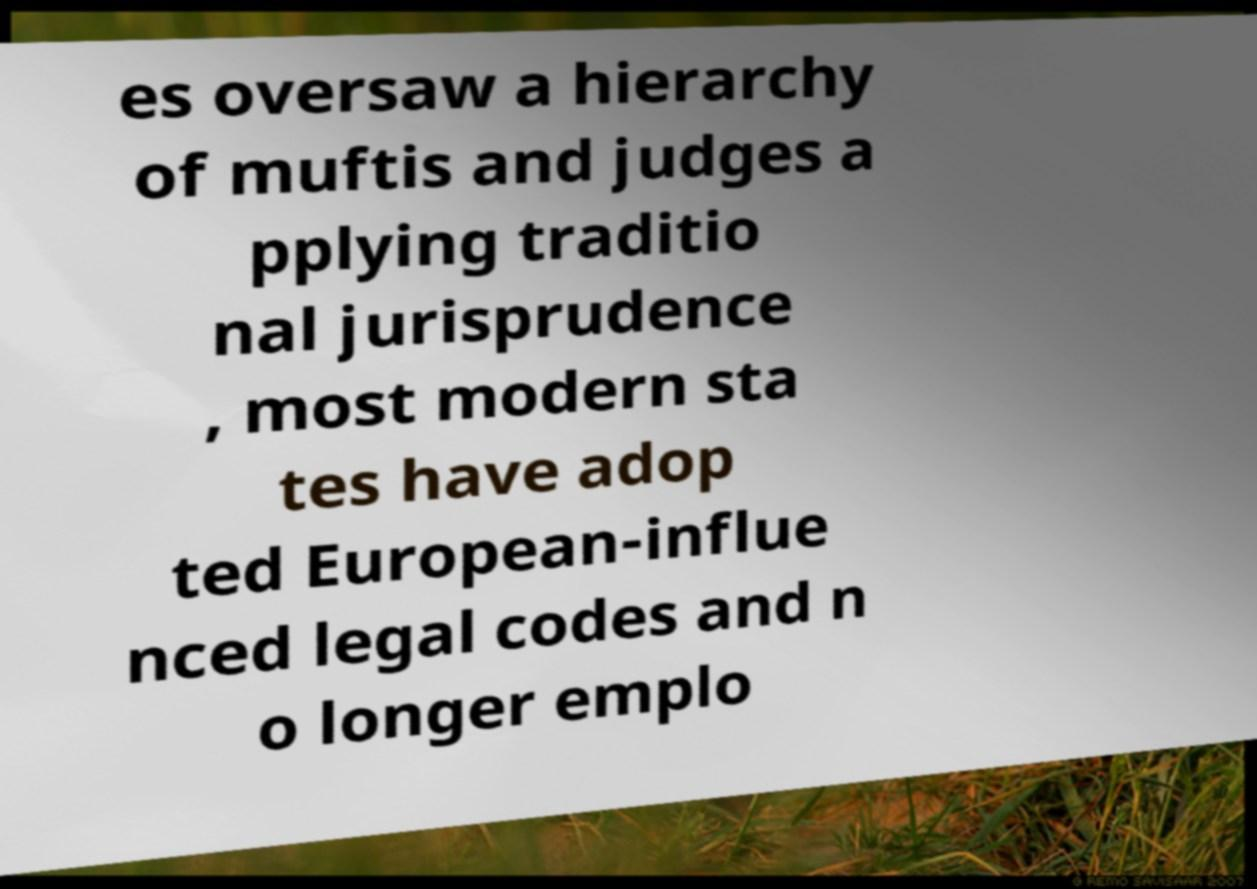There's text embedded in this image that I need extracted. Can you transcribe it verbatim? es oversaw a hierarchy of muftis and judges a pplying traditio nal jurisprudence , most modern sta tes have adop ted European-influe nced legal codes and n o longer emplo 